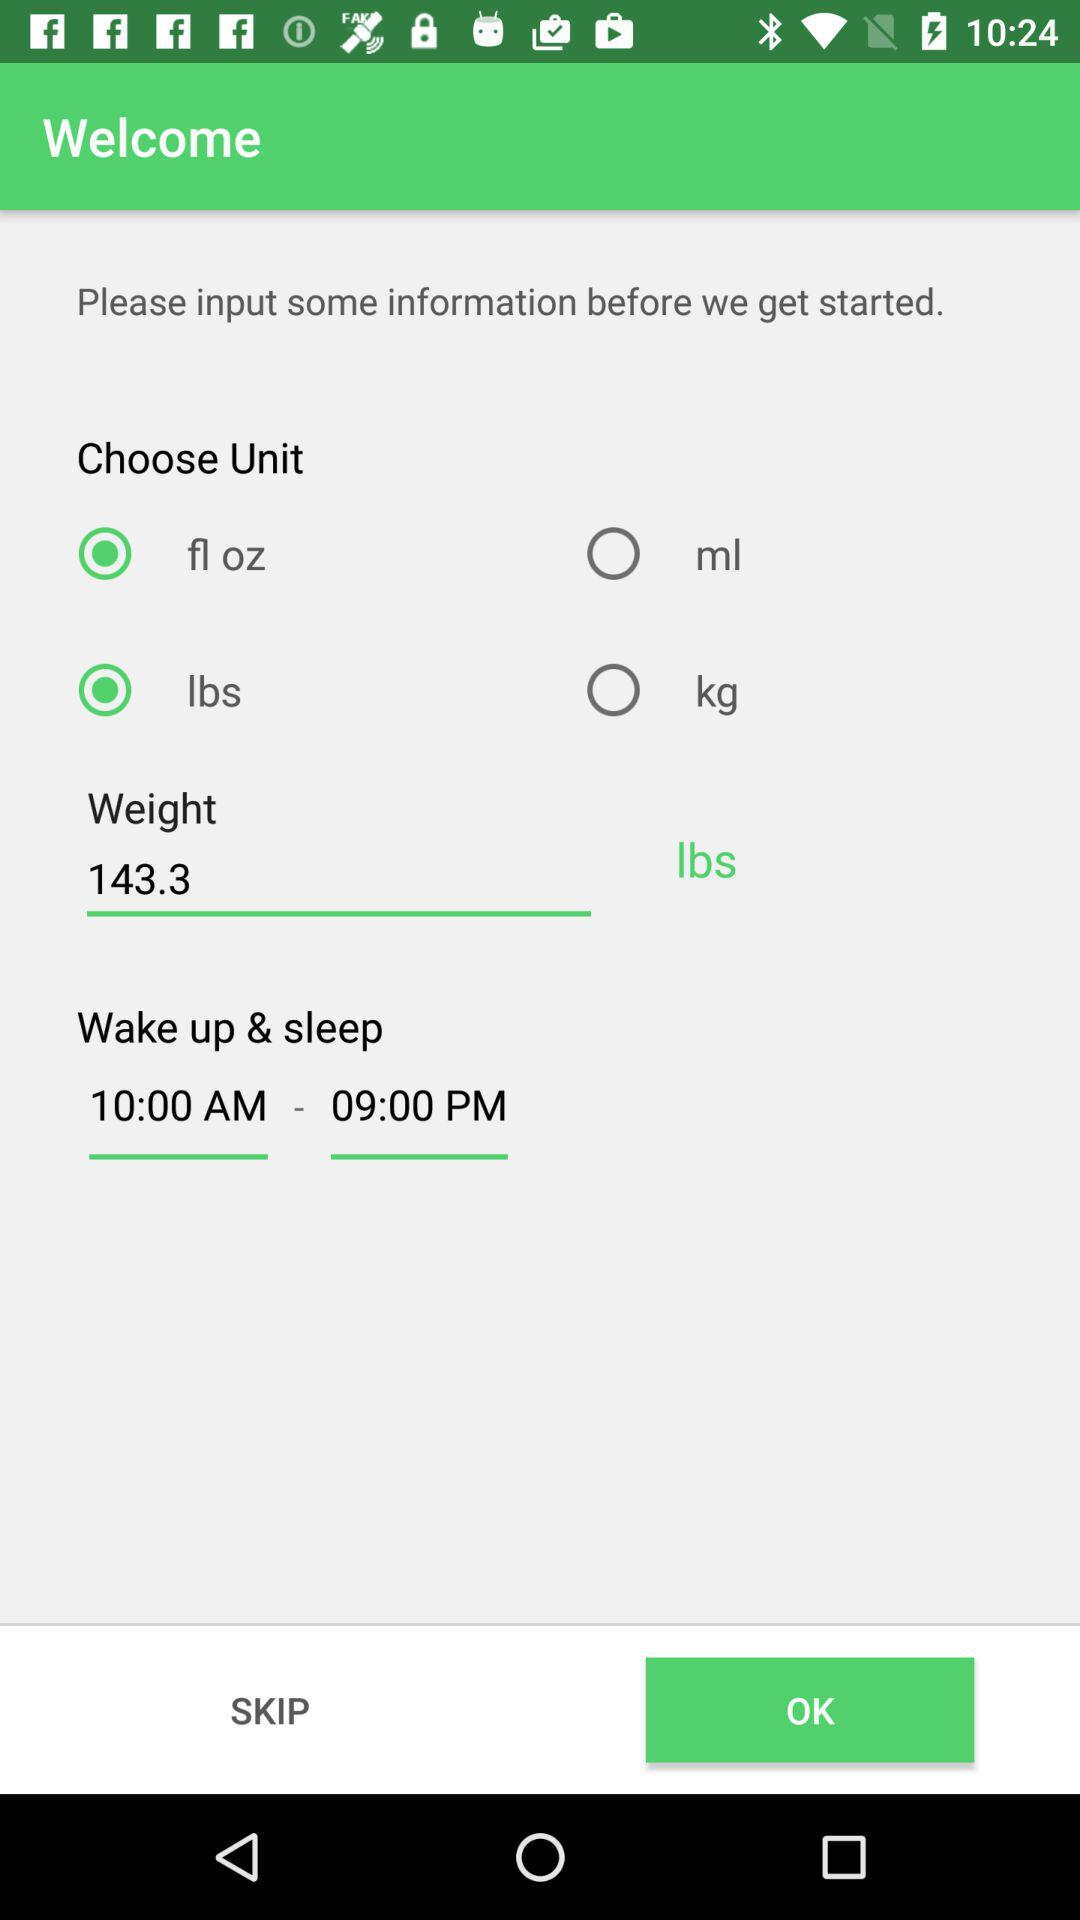What is the name of the application?
When the provided information is insufficient, respond with <no answer>. <no answer> 